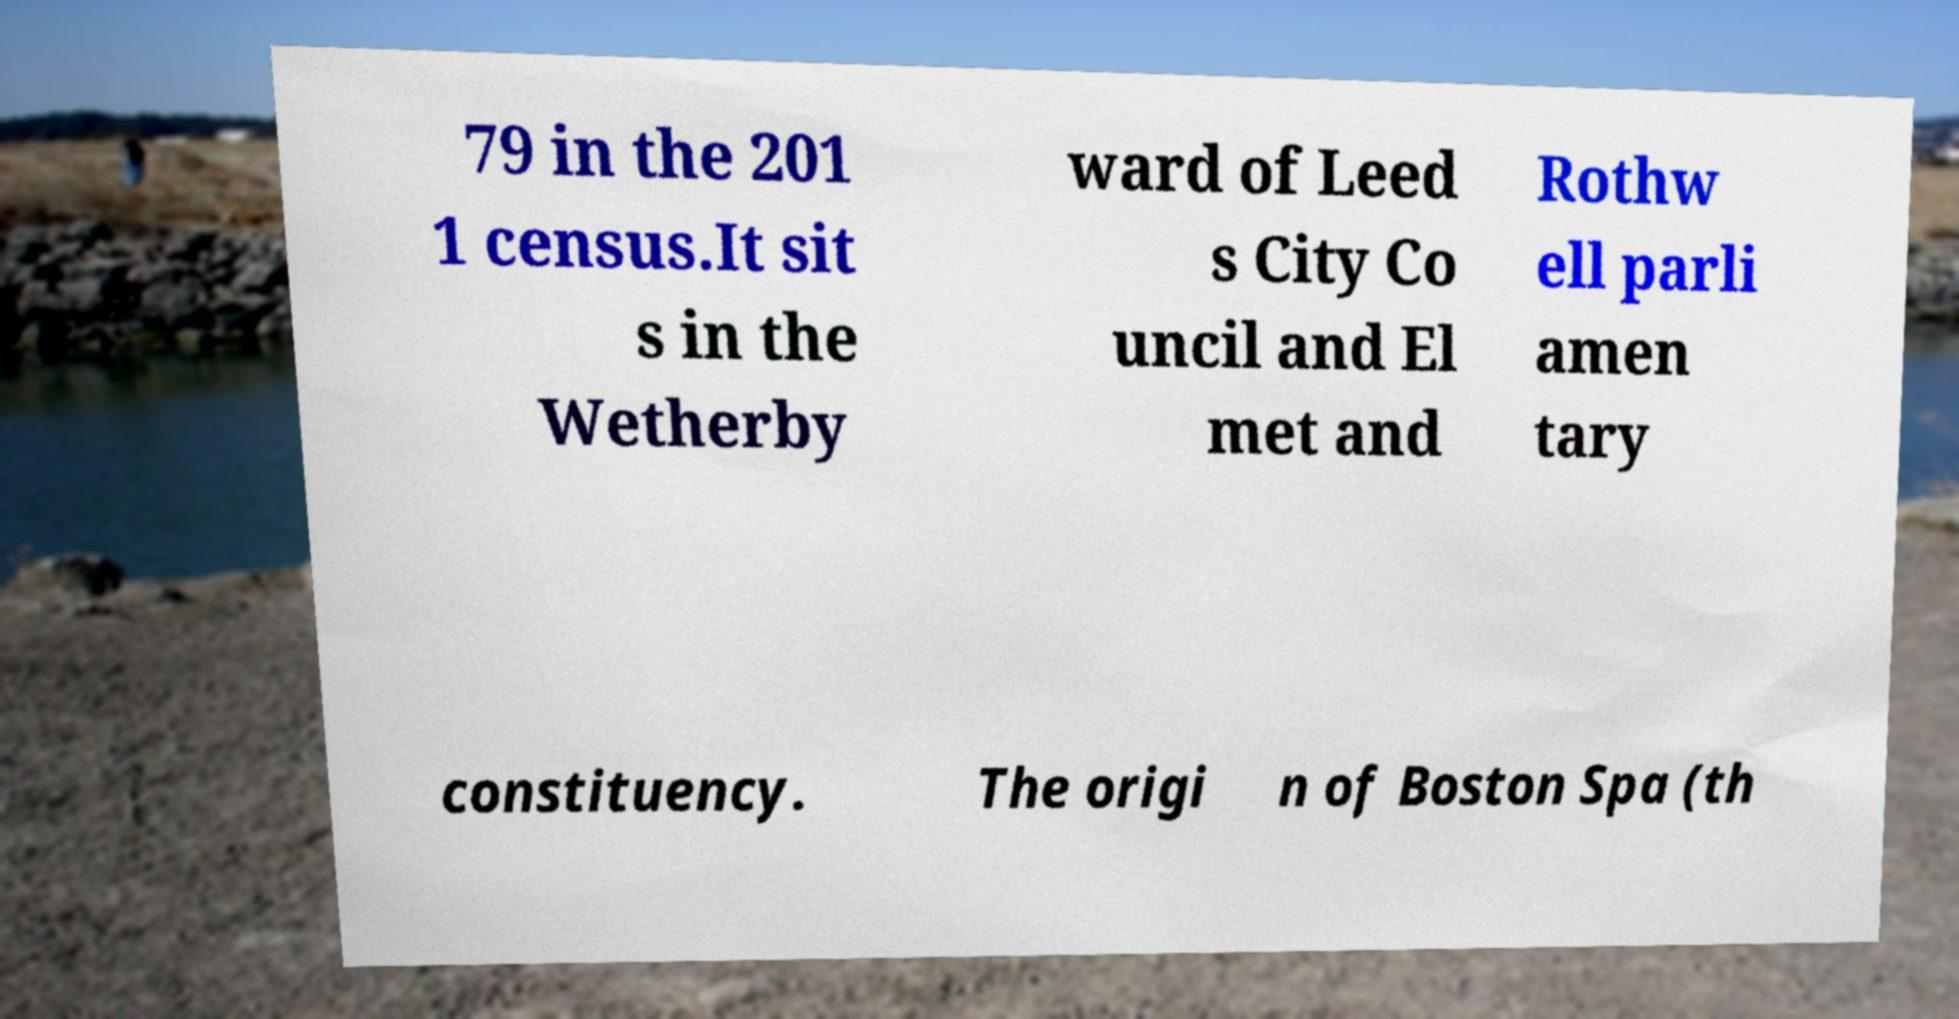Can you accurately transcribe the text from the provided image for me? 79 in the 201 1 census.It sit s in the Wetherby ward of Leed s City Co uncil and El met and Rothw ell parli amen tary constituency. The origi n of Boston Spa (th 